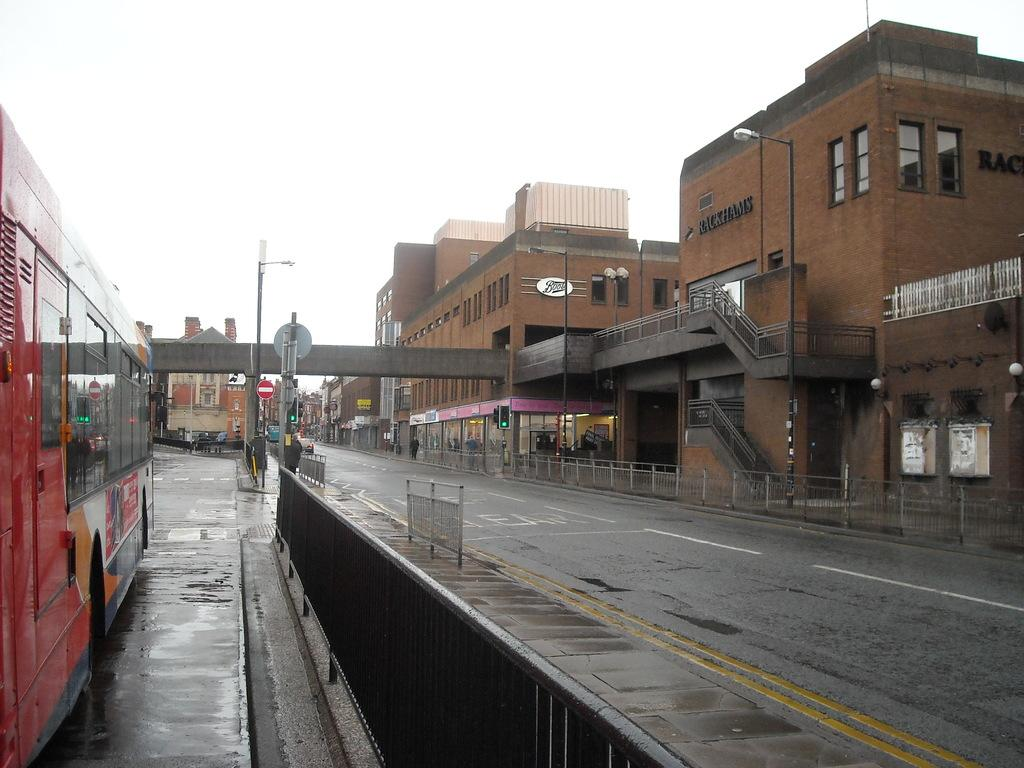<image>
Relay a brief, clear account of the picture shown. the letter B is on a sign on a brown building 